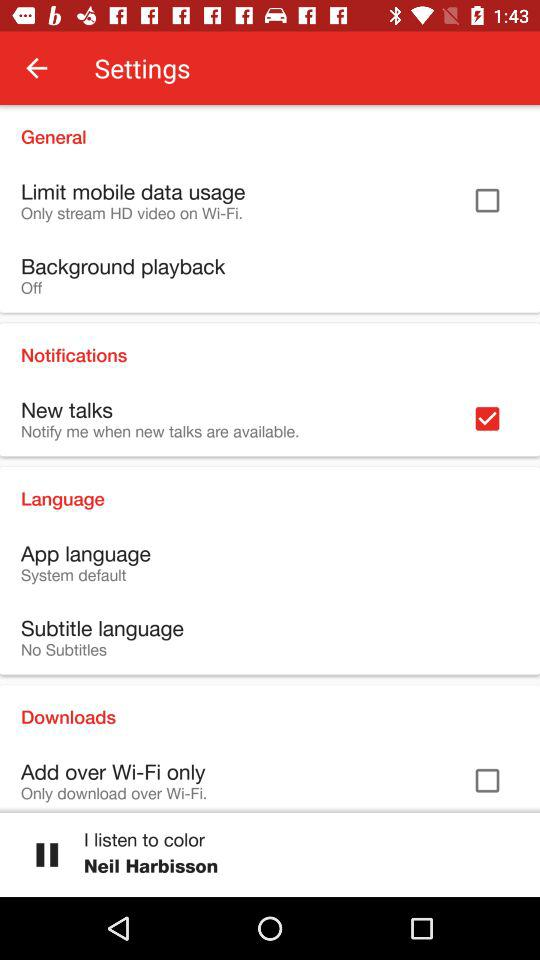Which audio is currently playing? The currently playing audio is "I listen to color". 